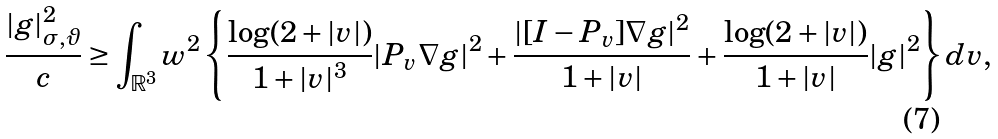Convert formula to latex. <formula><loc_0><loc_0><loc_500><loc_500>\frac { | g | _ { \sigma , \vartheta } ^ { 2 } } { c } \geq \int _ { \mathbb { R } ^ { 3 } } w ^ { 2 } \left \{ \frac { \log ( 2 + | v | ) } { 1 + | v | ^ { 3 } } | P _ { v } \nabla g | ^ { 2 } + \frac { | [ I - P _ { v } ] \nabla g | ^ { 2 } } { 1 + | v | } + \frac { \log ( 2 + | v | ) } { 1 + | v | } | g | ^ { 2 } \right \} d v ,</formula> 